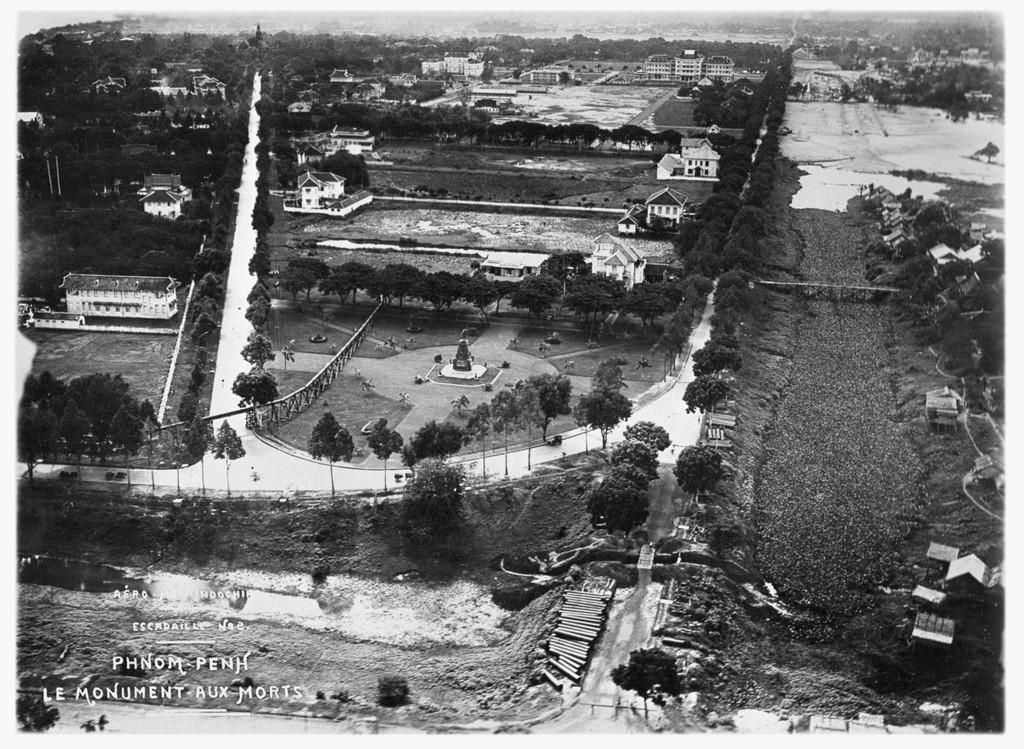What is the color scheme of the image? The image is black and white. What type of scene is depicted in the image? It is a top view of a city. Is there any text present in the image? Yes, there is some text in the left bottom corner of the image. Can you see any lakes in the image? There are no lakes visible in the image, as it is a top view of a city. How many feet are visible in the image? There are no feet present in the image. What is the zinc content in the image? There is no mention of zinc or any chemical elements in the image. 